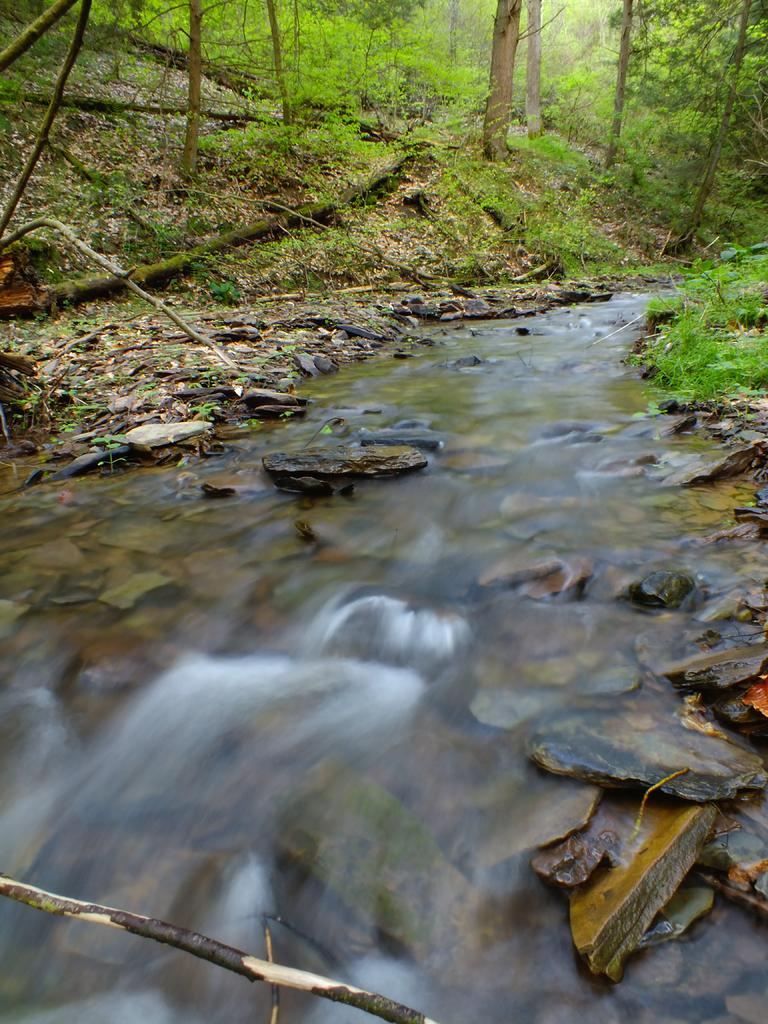What is the main feature in the middle of the image? There is a stream of water in the middle of the image. What type of vegetation can be seen on either side of the stream? There are trees on either side of the stream. What can be found on the ground in the image? Stones, wooden sticks, and small plants are present on the ground in the image. What type of cherry is growing on the trees in the image? There are no cherries present in the image; the trees are not specified as cherry trees. What answer can be found in the image? The image does not contain any answers, as it is a visual representation and not a source of information or knowledge. 